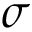<formula> <loc_0><loc_0><loc_500><loc_500>\sigma</formula> 